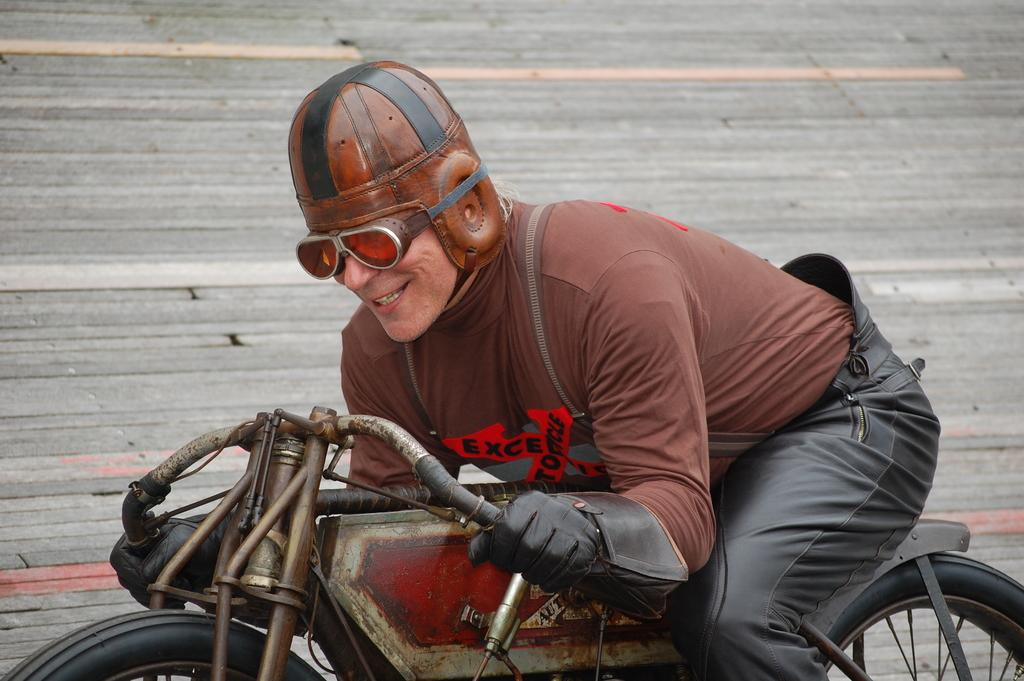Who is the main subject in the image? There is a man in the image. What is the man doing in the image? The man is riding a bicycle. What type of jewel is the man wearing around his neck in the image? There is no jewel visible around the man's neck in the image. Where is the lunchroom located in the image? There is no lunchroom present in the image; it features a man riding a bicycle. 